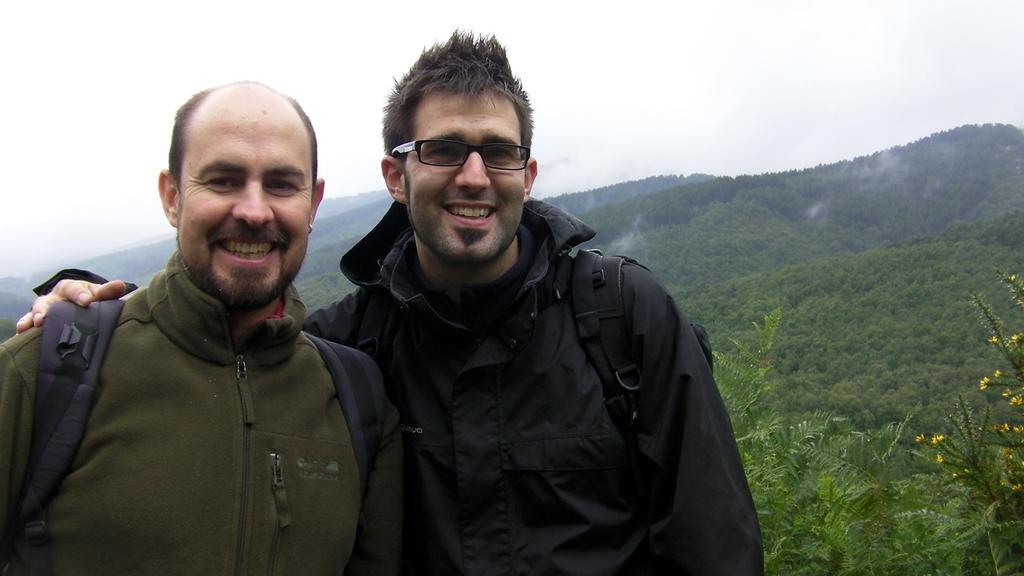Could you give a brief overview of what you see in this image? In the picture we can see two men wearing jacket, carrying backpacks, standing and posing for a photograph and in the background of the picture there are some mountains and top of the picture there is clear sky. 